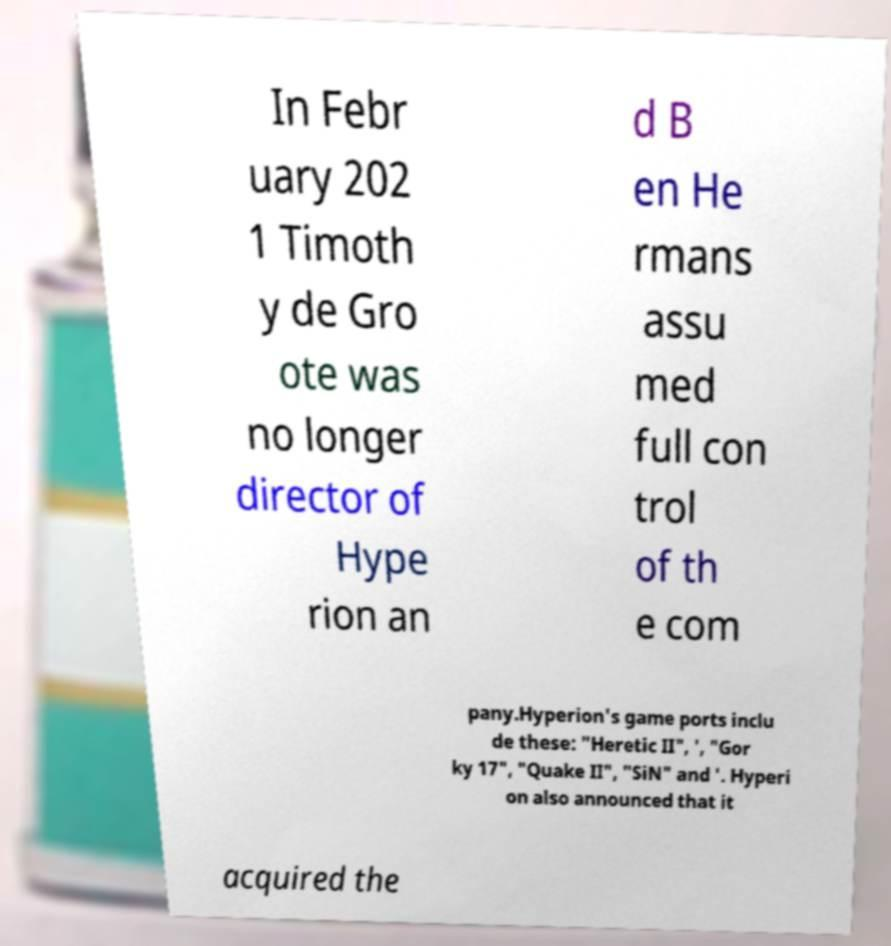There's text embedded in this image that I need extracted. Can you transcribe it verbatim? In Febr uary 202 1 Timoth y de Gro ote was no longer director of Hype rion an d B en He rmans assu med full con trol of th e com pany.Hyperion's game ports inclu de these: "Heretic II", ', "Gor ky 17", "Quake II", "SiN" and '. Hyperi on also announced that it acquired the 